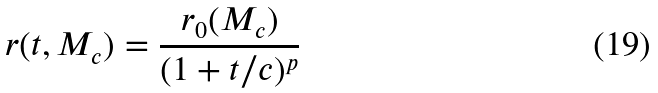<formula> <loc_0><loc_0><loc_500><loc_500>r ( t , M _ { c } ) = \frac { r _ { 0 } ( M _ { c } ) } { ( 1 + t / c ) ^ { p } }</formula> 